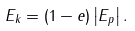Convert formula to latex. <formula><loc_0><loc_0><loc_500><loc_500>E _ { k } = ( 1 - e ) \left | E _ { p } \right | .</formula> 